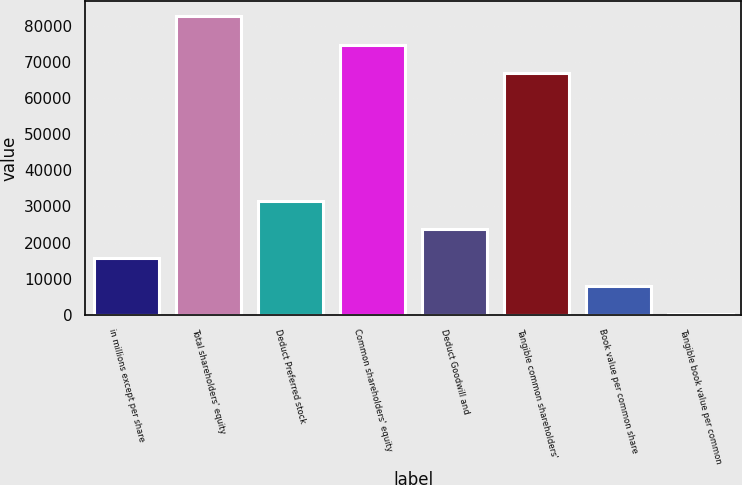Convert chart to OTSL. <chart><loc_0><loc_0><loc_500><loc_500><bar_chart><fcel>in millions except per share<fcel>Total shareholders' equity<fcel>Deduct Preferred stock<fcel>Common shareholders' equity<fcel>Deduct Goodwill and<fcel>Tangible common shareholders'<fcel>Book value per common share<fcel>Tangible book value per common<nl><fcel>15807.9<fcel>82555.8<fcel>31472.7<fcel>74723.4<fcel>23640.3<fcel>66891<fcel>7975.5<fcel>143.11<nl></chart> 